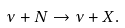Convert formula to latex. <formula><loc_0><loc_0><loc_500><loc_500>\nu + N \rightarrow \nu + X .</formula> 